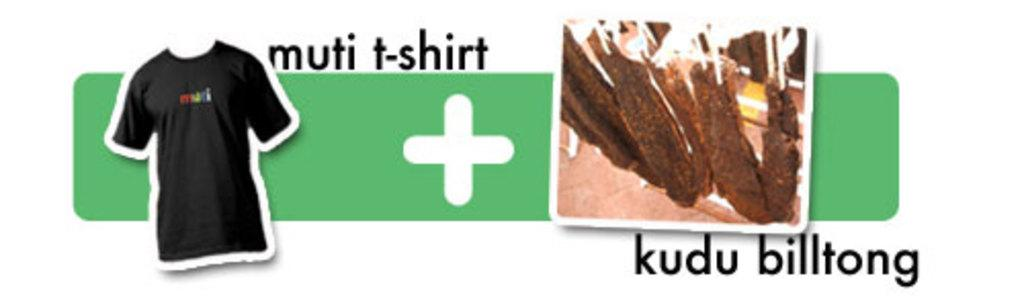Provide a one-sentence caption for the provided image. A t-shirt with a sign that says muti t-shirt + kudu billtong. 